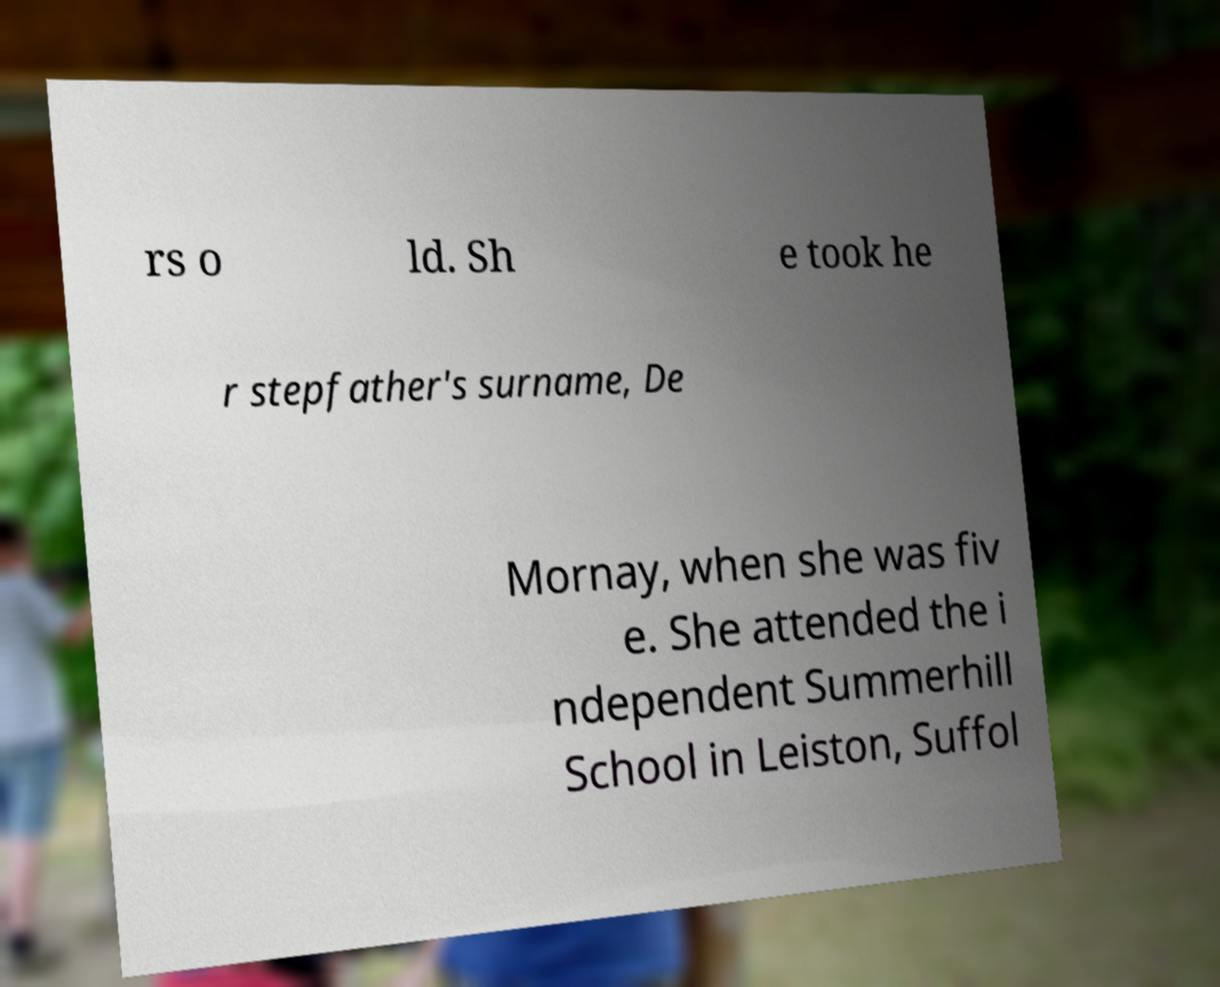I need the written content from this picture converted into text. Can you do that? rs o ld. Sh e took he r stepfather's surname, De Mornay, when she was fiv e. She attended the i ndependent Summerhill School in Leiston, Suffol 